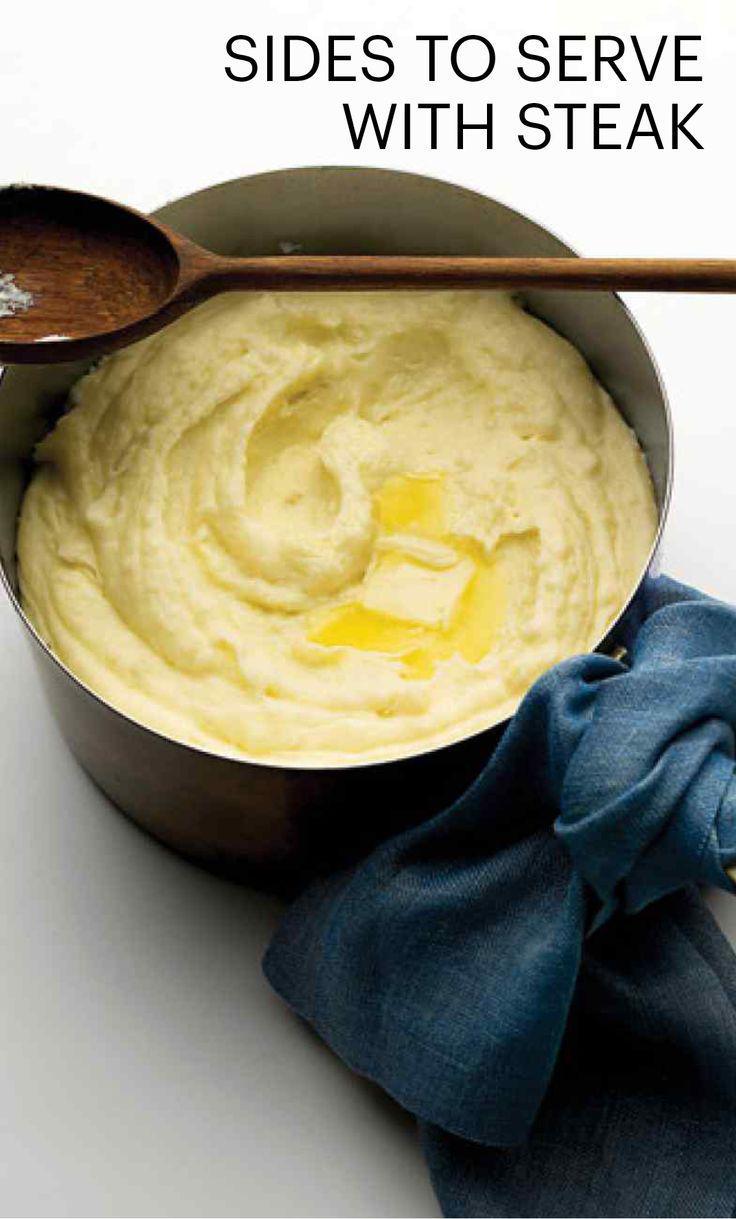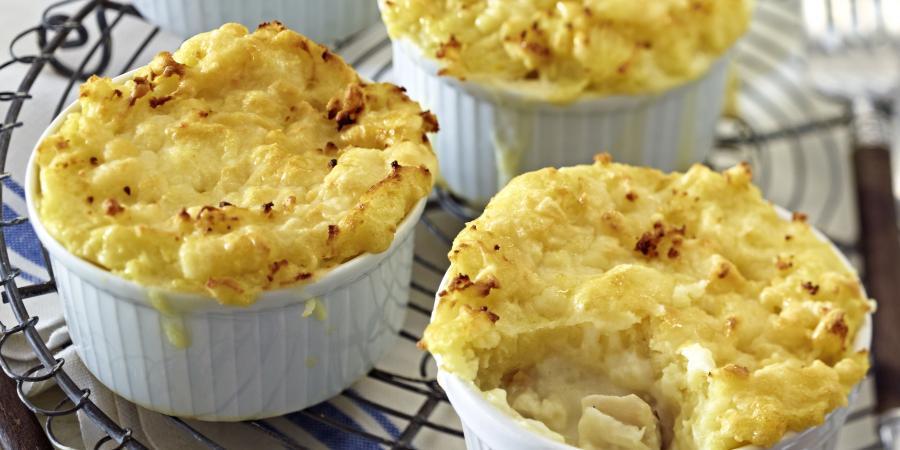The first image is the image on the left, the second image is the image on the right. Analyze the images presented: Is the assertion "There is one bowl of potatoes with a sprig of greenery on it in at least one of the images." valid? Answer yes or no. No. 